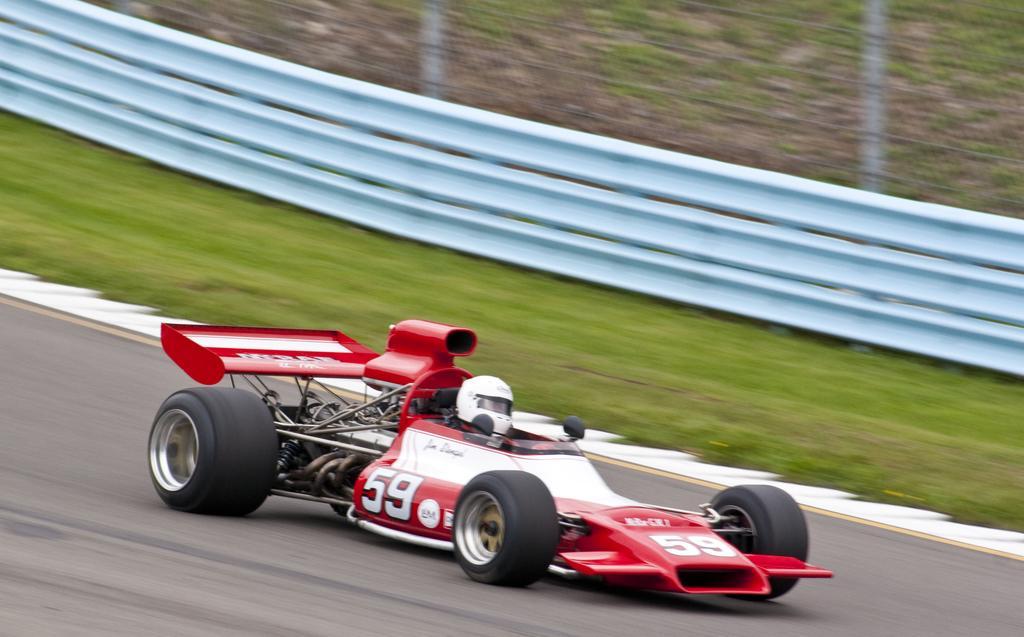Can you describe this image briefly? In this image we can see a person wearing a helmet sitting in a sports car which is on the road. On the backside we can see some grass and a metal fence. 